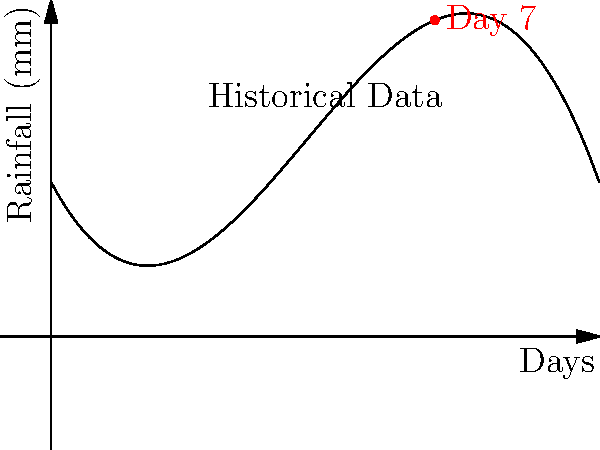As a weather reporter, you've been analyzing historical rainfall data for the Midwest region. The data has been fitted to a polynomial function $f(x) = -0.5x^3 + 7x^2 - 20x + 30$, where $x$ represents the number of days since the start of the month and $f(x)$ represents the predicted rainfall in millimeters. Based on this model, what is the predicted rainfall for the 7th day of the month? Round your answer to the nearest whole number. To solve this problem, we need to follow these steps:

1) We are given the polynomial function: $f(x) = -0.5x^3 + 7x^2 - 20x + 30$

2) We need to find $f(7)$, as we want the prediction for the 7th day.

3) Let's substitute $x = 7$ into the function:

   $f(7) = -0.5(7^3) + 7(7^2) - 20(7) + 30$

4) Now, let's calculate each term:
   - $-0.5(7^3) = -0.5(343) = -171.5$
   - $7(7^2) = 7(49) = 343$
   - $-20(7) = -140$
   - $30$ remains as is

5) Adding these terms:
   $f(7) = -171.5 + 343 - 140 + 30 = 61.5$

6) Rounding to the nearest whole number:
   $61.5$ rounds to $62$

Therefore, the predicted rainfall for the 7th day of the month is 62 mm.
Answer: 62 mm 